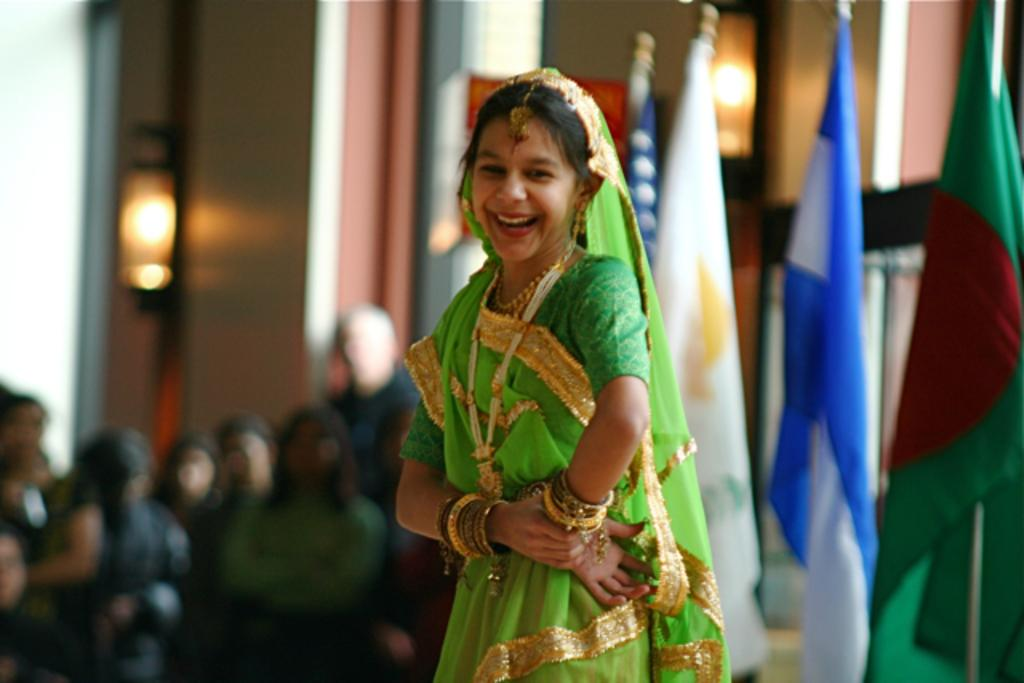Who is the main subject in the image? There is a girl in the image. What is the girl wearing? The girl is wearing a costume. What is the girl doing in the image? The girl is dancing and smiling. What can be seen on the right side of the image? There are flags on the right side of the image. What are the people on the left side of the image doing? The people on the left side of the image are sitting. How would you describe the background of the image? The background of the image is blurred. What type of animal is flying in the image? There is no animal flying in the image; it features a girl dancing and smiling. 